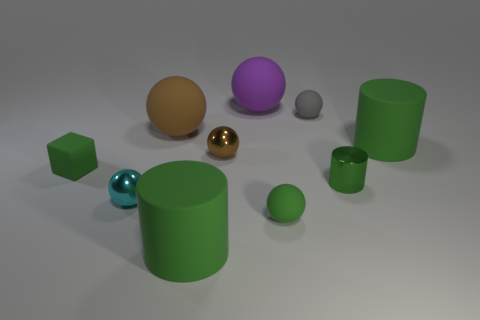Do the large green matte thing that is behind the small block and the small gray thing have the same shape? no 